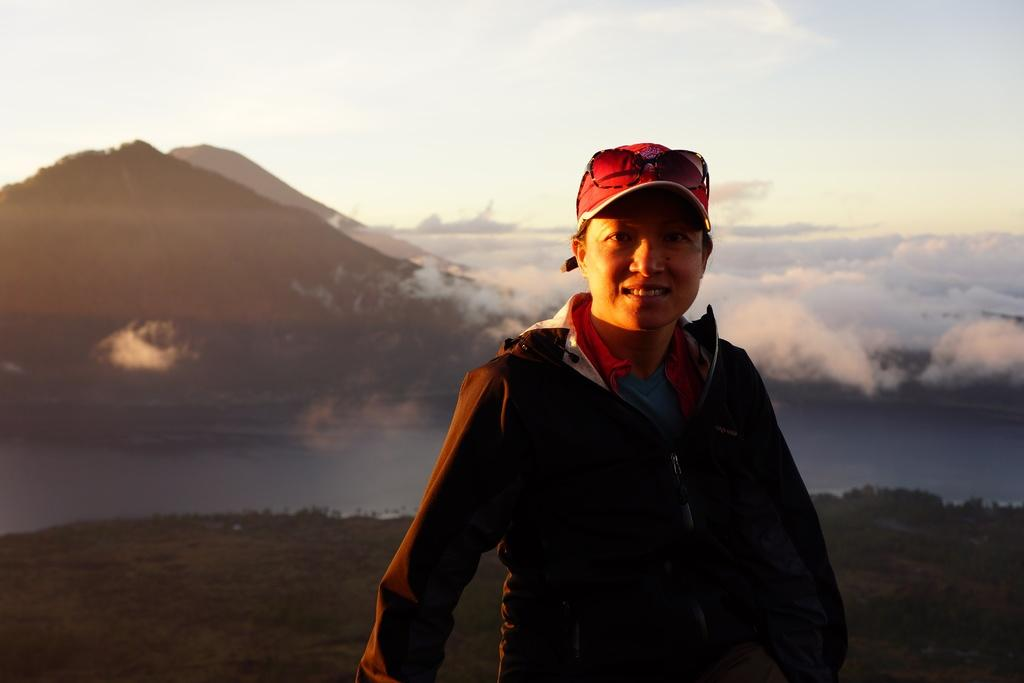What is the main subject of the image? There is a person standing in the middle of the image. What is the person's expression in the image? The person is smiling. What can be seen behind the person in the image? There is water visible behind the person. What type of landscape is visible in the background of the image? There are hills in the background of the image. What is visible in the sky in the image? There are clouds in the sky, and the sky is visible in the image. How many lizards are sitting on the yoke in the image? There are no lizards or yokes present in the image. What type of riddle is the person solving in the image? There is no riddle being solved in the image; the person is simply standing and smiling. 